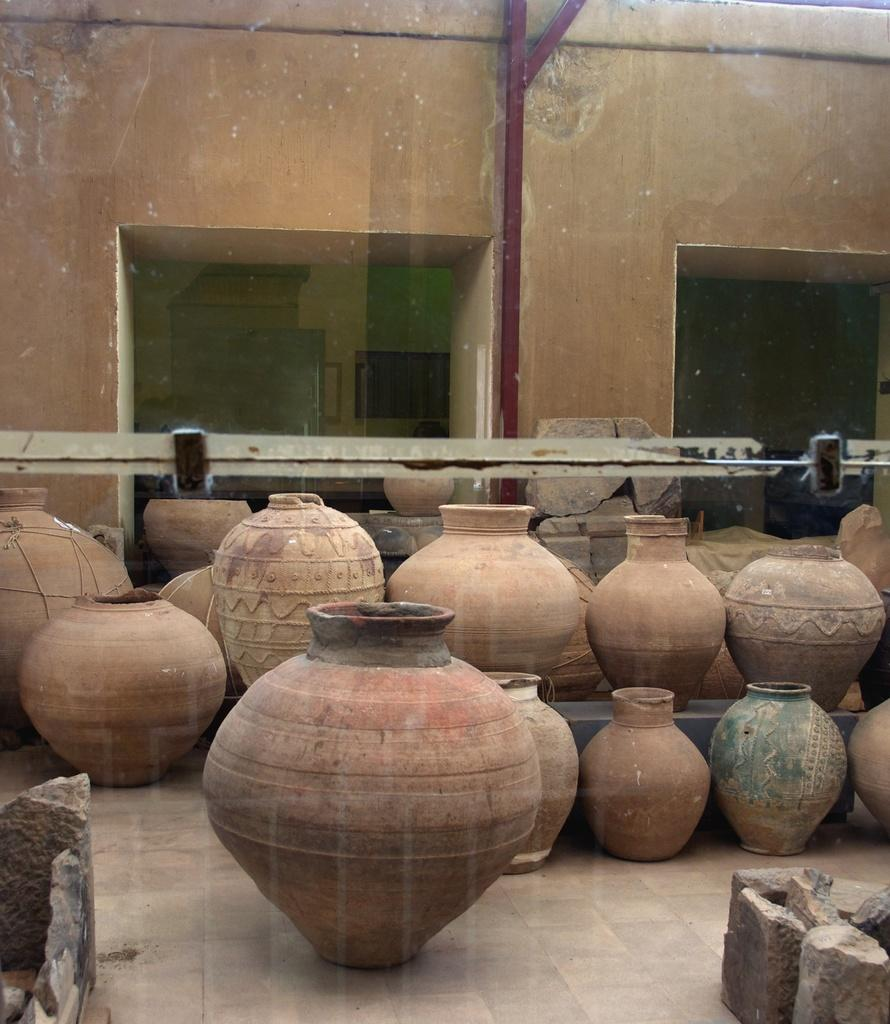What objects are present on the floor in the image? There are pots kept on the floor in the image. What type of surface is visible beneath the pots? There is a floor visible in the image. What can be seen on the right side of the image? There are rocks on the right side of the image. What is visible in the background of the image? There is a wall and a metal rod in the background of the image. What color are the queen's eyes in the image? There is no queen present in the image, so it is not possible to determine the color of her eyes. 